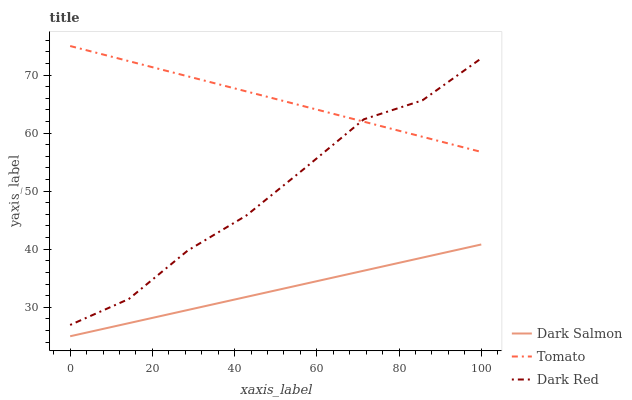Does Dark Salmon have the minimum area under the curve?
Answer yes or no. Yes. Does Tomato have the maximum area under the curve?
Answer yes or no. Yes. Does Dark Red have the minimum area under the curve?
Answer yes or no. No. Does Dark Red have the maximum area under the curve?
Answer yes or no. No. Is Tomato the smoothest?
Answer yes or no. Yes. Is Dark Red the roughest?
Answer yes or no. Yes. Is Dark Salmon the smoothest?
Answer yes or no. No. Is Dark Salmon the roughest?
Answer yes or no. No. Does Dark Salmon have the lowest value?
Answer yes or no. Yes. Does Dark Red have the lowest value?
Answer yes or no. No. Does Tomato have the highest value?
Answer yes or no. Yes. Does Dark Red have the highest value?
Answer yes or no. No. Is Dark Salmon less than Dark Red?
Answer yes or no. Yes. Is Tomato greater than Dark Salmon?
Answer yes or no. Yes. Does Tomato intersect Dark Red?
Answer yes or no. Yes. Is Tomato less than Dark Red?
Answer yes or no. No. Is Tomato greater than Dark Red?
Answer yes or no. No. Does Dark Salmon intersect Dark Red?
Answer yes or no. No. 